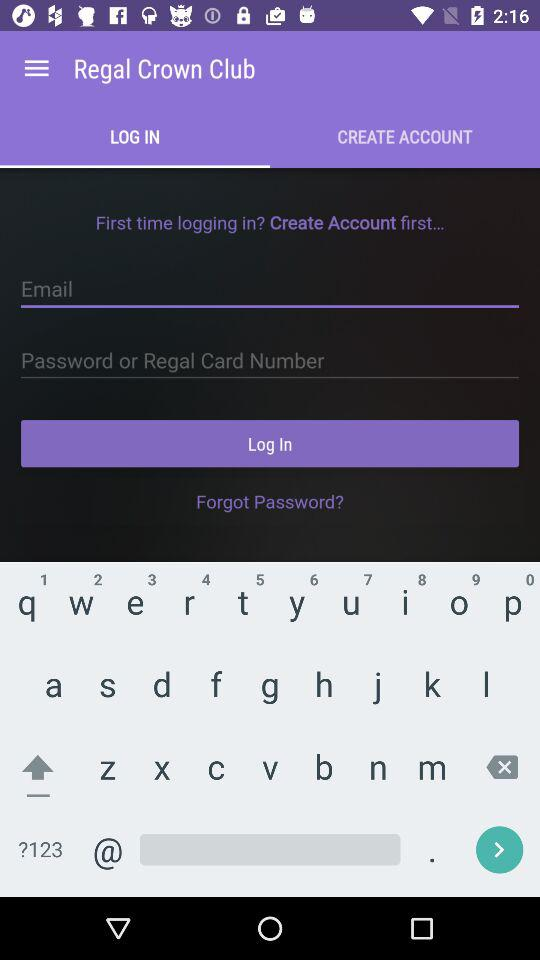What is the email address?
When the provided information is insufficient, respond with <no answer>. <no answer> 